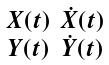Convert formula to latex. <formula><loc_0><loc_0><loc_500><loc_500>\begin{smallmatrix} X ( t ) & \dot { X } ( t ) \\ Y ( t ) & \dot { Y } ( t ) \end{smallmatrix}</formula> 